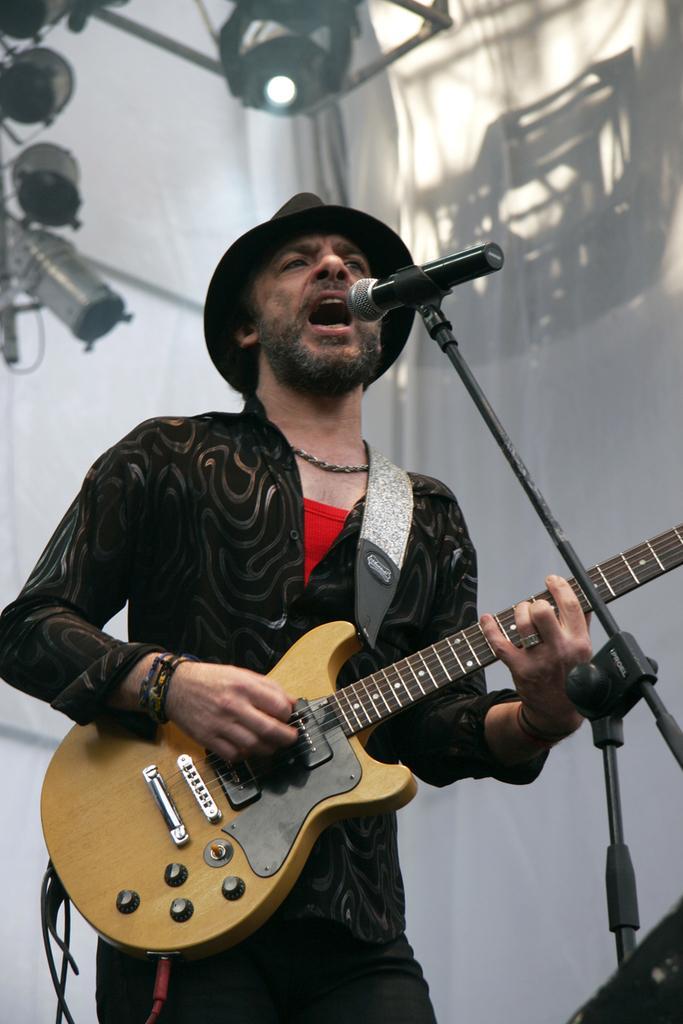In one or two sentences, can you explain what this image depicts? In this picture we can see man holding guitar in his hand and playing it and singing on mic and in background we can see cloth, lights. 